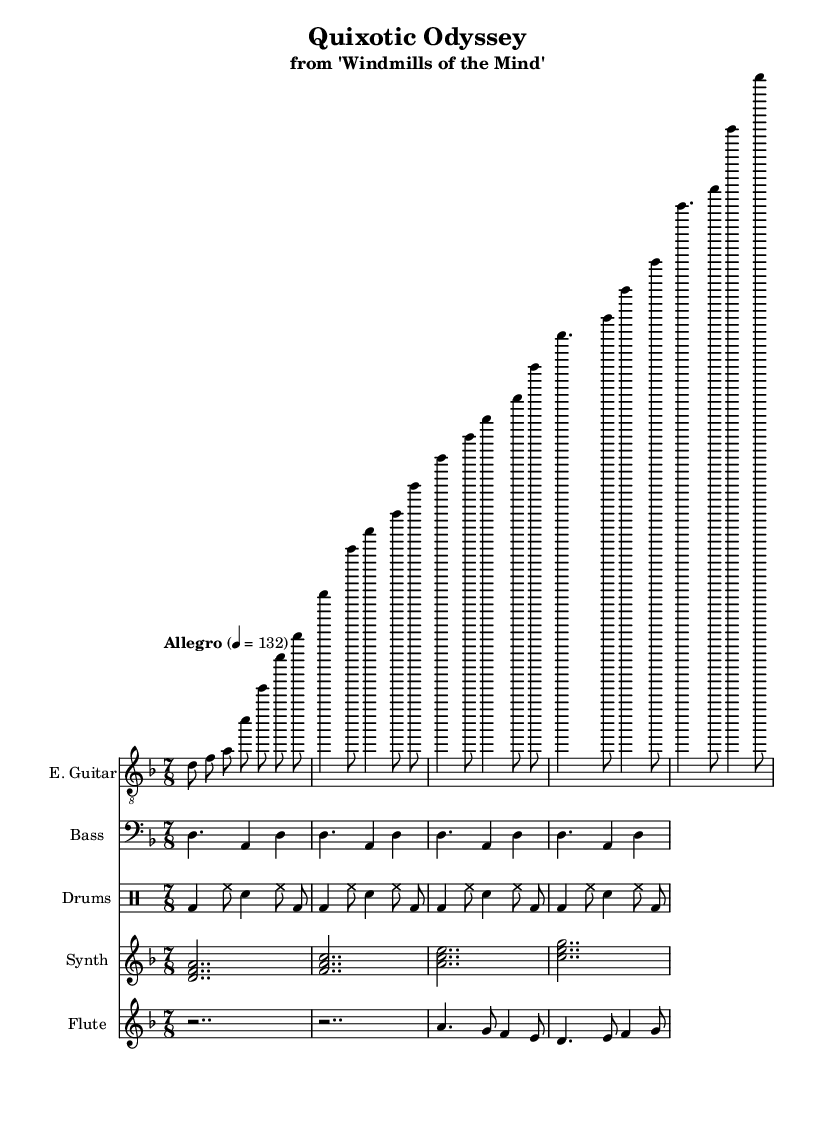What is the key signature of this music? The key signature is indicated at the beginning of the score. In this case, it shows D minor, which has one flat.
Answer: D minor What is the time signature of the piece? The time signature, found in the beginning of the score, is indicated as 7/8. This means there are seven eighth notes per measure.
Answer: 7/8 What is the tempo marking indicated in the sheet music? The tempo marking is found under the global section, stating "Allegro" with a metronome marking of quarter note equal to 132 beats per minute.
Answer: Allegro, 132 How many instruments are showcased in this score? By counting the different staff sections in the score, we see five distinct instruments: Electric Guitar, Bass, Drums, Synth, and Flute.
Answer: Five Which part has a simple bass line for demonstration? The bass line is clearly labeled and consists of notes under the "Bass" instrument section, showing a repeating pattern.
Answer: Bass Which sign indicates a short note before the melodic interlude for the flute? The rest sign (r) appears before the melodic interlude in the flute staff, indicating silence for that duration.
Answer: Rest What style does this music represent, based on the concept album theme? The music embodies progressive rock characteristics, as indicated by the elaborate structure and integration of literary themes, specifically referencing the work 'Windmills of the Mind'.
Answer: Progressive Rock 